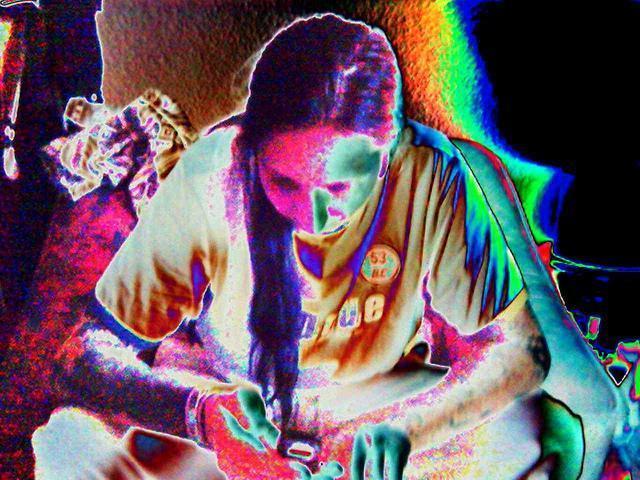How many sheep are in this picture?
Give a very brief answer. 0. 